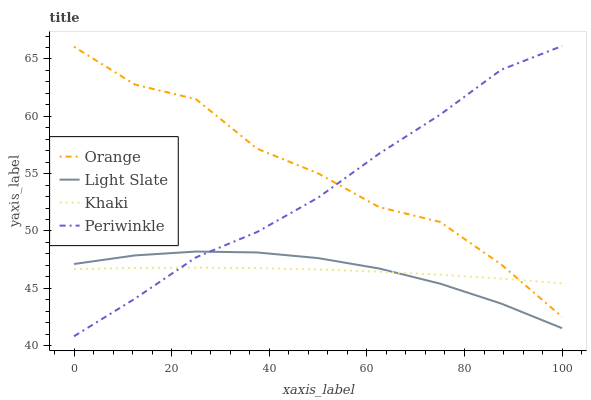Does Khaki have the minimum area under the curve?
Answer yes or no. Yes. Does Orange have the maximum area under the curve?
Answer yes or no. Yes. Does Light Slate have the minimum area under the curve?
Answer yes or no. No. Does Light Slate have the maximum area under the curve?
Answer yes or no. No. Is Khaki the smoothest?
Answer yes or no. Yes. Is Orange the roughest?
Answer yes or no. Yes. Is Light Slate the smoothest?
Answer yes or no. No. Is Light Slate the roughest?
Answer yes or no. No. Does Periwinkle have the lowest value?
Answer yes or no. Yes. Does Light Slate have the lowest value?
Answer yes or no. No. Does Periwinkle have the highest value?
Answer yes or no. Yes. Does Light Slate have the highest value?
Answer yes or no. No. Is Light Slate less than Orange?
Answer yes or no. Yes. Is Orange greater than Light Slate?
Answer yes or no. Yes. Does Khaki intersect Light Slate?
Answer yes or no. Yes. Is Khaki less than Light Slate?
Answer yes or no. No. Is Khaki greater than Light Slate?
Answer yes or no. No. Does Light Slate intersect Orange?
Answer yes or no. No. 